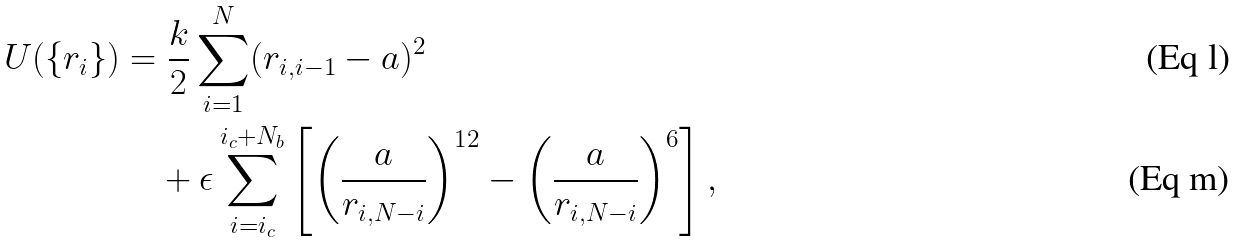Convert formula to latex. <formula><loc_0><loc_0><loc_500><loc_500>U ( \{ r _ { i } \} ) & = \frac { k } { 2 } \sum _ { i = 1 } ^ { N } ( r _ { i , i - 1 } - a ) ^ { 2 } \\ & \quad + \epsilon \sum _ { i = i _ { c } } ^ { i _ { c } + N _ { b } } \left [ \left ( \frac { a } { r _ { i , N - i } } \right ) ^ { 1 2 } - \left ( \frac { a } { r _ { i , N - i } } \right ) ^ { 6 } \right ] ,</formula> 